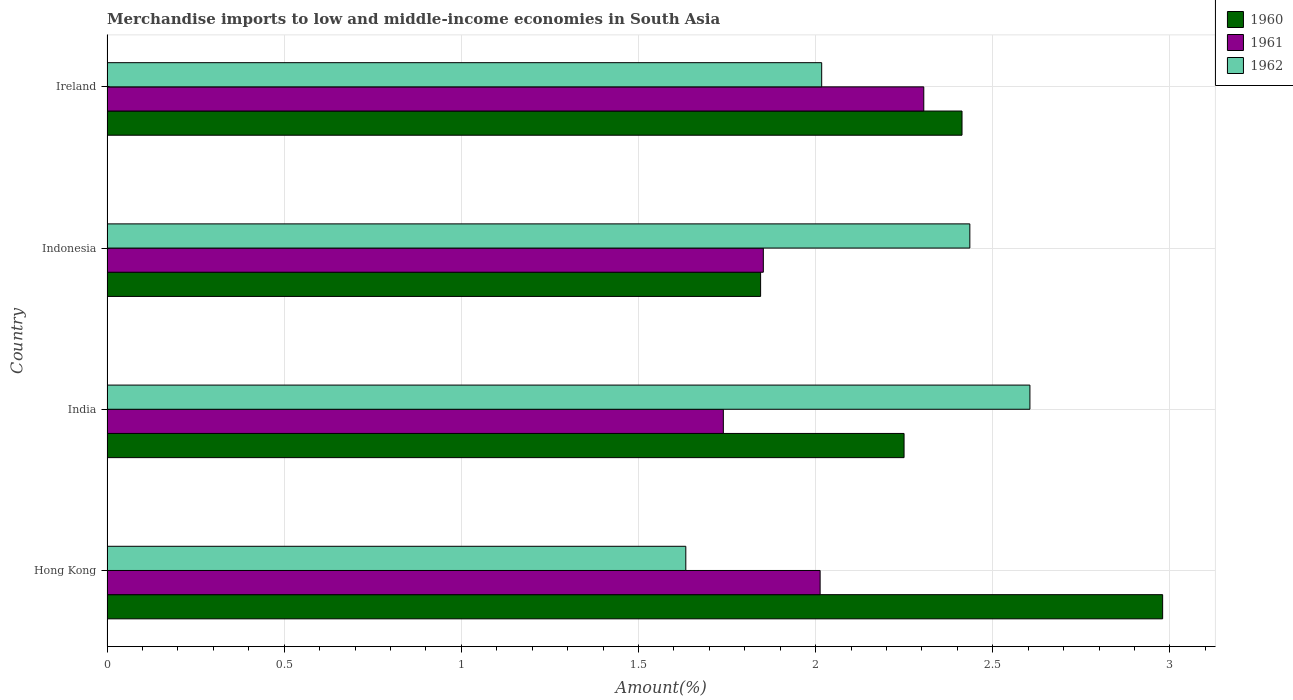How many different coloured bars are there?
Offer a very short reply. 3. What is the label of the 1st group of bars from the top?
Your answer should be very brief. Ireland. In how many cases, is the number of bars for a given country not equal to the number of legend labels?
Offer a very short reply. 0. What is the percentage of amount earned from merchandise imports in 1962 in India?
Give a very brief answer. 2.6. Across all countries, what is the maximum percentage of amount earned from merchandise imports in 1962?
Provide a succinct answer. 2.6. Across all countries, what is the minimum percentage of amount earned from merchandise imports in 1962?
Make the answer very short. 1.63. In which country was the percentage of amount earned from merchandise imports in 1960 maximum?
Your answer should be very brief. Hong Kong. In which country was the percentage of amount earned from merchandise imports in 1962 minimum?
Ensure brevity in your answer.  Hong Kong. What is the total percentage of amount earned from merchandise imports in 1962 in the graph?
Ensure brevity in your answer.  8.69. What is the difference between the percentage of amount earned from merchandise imports in 1962 in Hong Kong and that in India?
Your answer should be compact. -0.97. What is the difference between the percentage of amount earned from merchandise imports in 1960 in India and the percentage of amount earned from merchandise imports in 1961 in Indonesia?
Ensure brevity in your answer.  0.4. What is the average percentage of amount earned from merchandise imports in 1962 per country?
Offer a terse response. 2.17. What is the difference between the percentage of amount earned from merchandise imports in 1960 and percentage of amount earned from merchandise imports in 1961 in Hong Kong?
Provide a short and direct response. 0.97. In how many countries, is the percentage of amount earned from merchandise imports in 1961 greater than 2.1 %?
Give a very brief answer. 1. What is the ratio of the percentage of amount earned from merchandise imports in 1962 in Hong Kong to that in Ireland?
Give a very brief answer. 0.81. Is the percentage of amount earned from merchandise imports in 1962 in Indonesia less than that in Ireland?
Offer a terse response. No. What is the difference between the highest and the second highest percentage of amount earned from merchandise imports in 1960?
Your response must be concise. 0.57. What is the difference between the highest and the lowest percentage of amount earned from merchandise imports in 1962?
Give a very brief answer. 0.97. Is the sum of the percentage of amount earned from merchandise imports in 1962 in Hong Kong and India greater than the maximum percentage of amount earned from merchandise imports in 1960 across all countries?
Provide a succinct answer. Yes. What does the 3rd bar from the top in Ireland represents?
Offer a terse response. 1960. Is it the case that in every country, the sum of the percentage of amount earned from merchandise imports in 1962 and percentage of amount earned from merchandise imports in 1961 is greater than the percentage of amount earned from merchandise imports in 1960?
Give a very brief answer. Yes. How many bars are there?
Your response must be concise. 12. Does the graph contain any zero values?
Your answer should be very brief. No. Does the graph contain grids?
Keep it short and to the point. Yes. Where does the legend appear in the graph?
Provide a succinct answer. Top right. How many legend labels are there?
Provide a short and direct response. 3. What is the title of the graph?
Your response must be concise. Merchandise imports to low and middle-income economies in South Asia. Does "2001" appear as one of the legend labels in the graph?
Make the answer very short. No. What is the label or title of the X-axis?
Your answer should be compact. Amount(%). What is the label or title of the Y-axis?
Keep it short and to the point. Country. What is the Amount(%) in 1960 in Hong Kong?
Offer a terse response. 2.98. What is the Amount(%) of 1961 in Hong Kong?
Offer a very short reply. 2.01. What is the Amount(%) in 1962 in Hong Kong?
Ensure brevity in your answer.  1.63. What is the Amount(%) of 1960 in India?
Provide a succinct answer. 2.25. What is the Amount(%) of 1961 in India?
Offer a very short reply. 1.74. What is the Amount(%) of 1962 in India?
Your answer should be very brief. 2.6. What is the Amount(%) of 1960 in Indonesia?
Offer a terse response. 1.84. What is the Amount(%) in 1961 in Indonesia?
Provide a succinct answer. 1.85. What is the Amount(%) in 1962 in Indonesia?
Make the answer very short. 2.44. What is the Amount(%) in 1960 in Ireland?
Offer a terse response. 2.41. What is the Amount(%) of 1961 in Ireland?
Provide a short and direct response. 2.31. What is the Amount(%) in 1962 in Ireland?
Give a very brief answer. 2.02. Across all countries, what is the maximum Amount(%) of 1960?
Make the answer very short. 2.98. Across all countries, what is the maximum Amount(%) of 1961?
Make the answer very short. 2.31. Across all countries, what is the maximum Amount(%) of 1962?
Offer a very short reply. 2.6. Across all countries, what is the minimum Amount(%) in 1960?
Offer a very short reply. 1.84. Across all countries, what is the minimum Amount(%) in 1961?
Your answer should be very brief. 1.74. Across all countries, what is the minimum Amount(%) in 1962?
Your answer should be very brief. 1.63. What is the total Amount(%) in 1960 in the graph?
Make the answer very short. 9.49. What is the total Amount(%) in 1961 in the graph?
Keep it short and to the point. 7.91. What is the total Amount(%) in 1962 in the graph?
Offer a very short reply. 8.69. What is the difference between the Amount(%) in 1960 in Hong Kong and that in India?
Your answer should be very brief. 0.73. What is the difference between the Amount(%) of 1961 in Hong Kong and that in India?
Provide a succinct answer. 0.27. What is the difference between the Amount(%) of 1962 in Hong Kong and that in India?
Your answer should be compact. -0.97. What is the difference between the Amount(%) of 1960 in Hong Kong and that in Indonesia?
Provide a short and direct response. 1.13. What is the difference between the Amount(%) of 1961 in Hong Kong and that in Indonesia?
Offer a terse response. 0.16. What is the difference between the Amount(%) of 1962 in Hong Kong and that in Indonesia?
Offer a terse response. -0.8. What is the difference between the Amount(%) of 1960 in Hong Kong and that in Ireland?
Your response must be concise. 0.57. What is the difference between the Amount(%) of 1961 in Hong Kong and that in Ireland?
Provide a succinct answer. -0.29. What is the difference between the Amount(%) in 1962 in Hong Kong and that in Ireland?
Provide a succinct answer. -0.38. What is the difference between the Amount(%) in 1960 in India and that in Indonesia?
Make the answer very short. 0.4. What is the difference between the Amount(%) of 1961 in India and that in Indonesia?
Give a very brief answer. -0.11. What is the difference between the Amount(%) in 1962 in India and that in Indonesia?
Your response must be concise. 0.17. What is the difference between the Amount(%) in 1960 in India and that in Ireland?
Offer a terse response. -0.16. What is the difference between the Amount(%) in 1961 in India and that in Ireland?
Your response must be concise. -0.57. What is the difference between the Amount(%) of 1962 in India and that in Ireland?
Offer a terse response. 0.59. What is the difference between the Amount(%) in 1960 in Indonesia and that in Ireland?
Give a very brief answer. -0.57. What is the difference between the Amount(%) of 1961 in Indonesia and that in Ireland?
Keep it short and to the point. -0.45. What is the difference between the Amount(%) in 1962 in Indonesia and that in Ireland?
Make the answer very short. 0.42. What is the difference between the Amount(%) in 1960 in Hong Kong and the Amount(%) in 1961 in India?
Give a very brief answer. 1.24. What is the difference between the Amount(%) of 1960 in Hong Kong and the Amount(%) of 1962 in India?
Give a very brief answer. 0.37. What is the difference between the Amount(%) of 1961 in Hong Kong and the Amount(%) of 1962 in India?
Your answer should be very brief. -0.59. What is the difference between the Amount(%) of 1960 in Hong Kong and the Amount(%) of 1961 in Indonesia?
Provide a succinct answer. 1.13. What is the difference between the Amount(%) of 1960 in Hong Kong and the Amount(%) of 1962 in Indonesia?
Keep it short and to the point. 0.54. What is the difference between the Amount(%) in 1961 in Hong Kong and the Amount(%) in 1962 in Indonesia?
Your answer should be very brief. -0.42. What is the difference between the Amount(%) of 1960 in Hong Kong and the Amount(%) of 1961 in Ireland?
Ensure brevity in your answer.  0.67. What is the difference between the Amount(%) of 1960 in Hong Kong and the Amount(%) of 1962 in Ireland?
Offer a very short reply. 0.96. What is the difference between the Amount(%) in 1961 in Hong Kong and the Amount(%) in 1962 in Ireland?
Give a very brief answer. -0. What is the difference between the Amount(%) in 1960 in India and the Amount(%) in 1961 in Indonesia?
Your answer should be compact. 0.4. What is the difference between the Amount(%) in 1960 in India and the Amount(%) in 1962 in Indonesia?
Provide a short and direct response. -0.19. What is the difference between the Amount(%) in 1961 in India and the Amount(%) in 1962 in Indonesia?
Your answer should be very brief. -0.7. What is the difference between the Amount(%) in 1960 in India and the Amount(%) in 1961 in Ireland?
Make the answer very short. -0.06. What is the difference between the Amount(%) in 1960 in India and the Amount(%) in 1962 in Ireland?
Give a very brief answer. 0.23. What is the difference between the Amount(%) of 1961 in India and the Amount(%) of 1962 in Ireland?
Offer a very short reply. -0.28. What is the difference between the Amount(%) in 1960 in Indonesia and the Amount(%) in 1961 in Ireland?
Offer a very short reply. -0.46. What is the difference between the Amount(%) of 1960 in Indonesia and the Amount(%) of 1962 in Ireland?
Your answer should be compact. -0.17. What is the difference between the Amount(%) in 1961 in Indonesia and the Amount(%) in 1962 in Ireland?
Provide a succinct answer. -0.16. What is the average Amount(%) of 1960 per country?
Make the answer very short. 2.37. What is the average Amount(%) in 1961 per country?
Give a very brief answer. 1.98. What is the average Amount(%) in 1962 per country?
Give a very brief answer. 2.17. What is the difference between the Amount(%) in 1960 and Amount(%) in 1961 in Hong Kong?
Your answer should be compact. 0.97. What is the difference between the Amount(%) of 1960 and Amount(%) of 1962 in Hong Kong?
Offer a terse response. 1.35. What is the difference between the Amount(%) of 1961 and Amount(%) of 1962 in Hong Kong?
Your response must be concise. 0.38. What is the difference between the Amount(%) in 1960 and Amount(%) in 1961 in India?
Keep it short and to the point. 0.51. What is the difference between the Amount(%) of 1960 and Amount(%) of 1962 in India?
Your answer should be very brief. -0.36. What is the difference between the Amount(%) in 1961 and Amount(%) in 1962 in India?
Your answer should be compact. -0.87. What is the difference between the Amount(%) in 1960 and Amount(%) in 1961 in Indonesia?
Your answer should be very brief. -0.01. What is the difference between the Amount(%) in 1960 and Amount(%) in 1962 in Indonesia?
Give a very brief answer. -0.59. What is the difference between the Amount(%) of 1961 and Amount(%) of 1962 in Indonesia?
Provide a succinct answer. -0.58. What is the difference between the Amount(%) in 1960 and Amount(%) in 1961 in Ireland?
Keep it short and to the point. 0.11. What is the difference between the Amount(%) of 1960 and Amount(%) of 1962 in Ireland?
Make the answer very short. 0.4. What is the difference between the Amount(%) in 1961 and Amount(%) in 1962 in Ireland?
Give a very brief answer. 0.29. What is the ratio of the Amount(%) of 1960 in Hong Kong to that in India?
Your answer should be compact. 1.32. What is the ratio of the Amount(%) in 1961 in Hong Kong to that in India?
Make the answer very short. 1.16. What is the ratio of the Amount(%) in 1962 in Hong Kong to that in India?
Make the answer very short. 0.63. What is the ratio of the Amount(%) in 1960 in Hong Kong to that in Indonesia?
Keep it short and to the point. 1.62. What is the ratio of the Amount(%) in 1961 in Hong Kong to that in Indonesia?
Keep it short and to the point. 1.09. What is the ratio of the Amount(%) of 1962 in Hong Kong to that in Indonesia?
Offer a very short reply. 0.67. What is the ratio of the Amount(%) in 1960 in Hong Kong to that in Ireland?
Offer a terse response. 1.23. What is the ratio of the Amount(%) in 1961 in Hong Kong to that in Ireland?
Provide a succinct answer. 0.87. What is the ratio of the Amount(%) of 1962 in Hong Kong to that in Ireland?
Your response must be concise. 0.81. What is the ratio of the Amount(%) of 1960 in India to that in Indonesia?
Ensure brevity in your answer.  1.22. What is the ratio of the Amount(%) in 1961 in India to that in Indonesia?
Give a very brief answer. 0.94. What is the ratio of the Amount(%) in 1962 in India to that in Indonesia?
Provide a succinct answer. 1.07. What is the ratio of the Amount(%) in 1960 in India to that in Ireland?
Your answer should be compact. 0.93. What is the ratio of the Amount(%) of 1961 in India to that in Ireland?
Your answer should be compact. 0.75. What is the ratio of the Amount(%) in 1962 in India to that in Ireland?
Provide a short and direct response. 1.29. What is the ratio of the Amount(%) of 1960 in Indonesia to that in Ireland?
Provide a short and direct response. 0.76. What is the ratio of the Amount(%) of 1961 in Indonesia to that in Ireland?
Ensure brevity in your answer.  0.8. What is the ratio of the Amount(%) in 1962 in Indonesia to that in Ireland?
Provide a succinct answer. 1.21. What is the difference between the highest and the second highest Amount(%) in 1960?
Ensure brevity in your answer.  0.57. What is the difference between the highest and the second highest Amount(%) in 1961?
Keep it short and to the point. 0.29. What is the difference between the highest and the second highest Amount(%) of 1962?
Make the answer very short. 0.17. What is the difference between the highest and the lowest Amount(%) in 1960?
Ensure brevity in your answer.  1.13. What is the difference between the highest and the lowest Amount(%) of 1961?
Provide a short and direct response. 0.57. What is the difference between the highest and the lowest Amount(%) of 1962?
Your answer should be very brief. 0.97. 